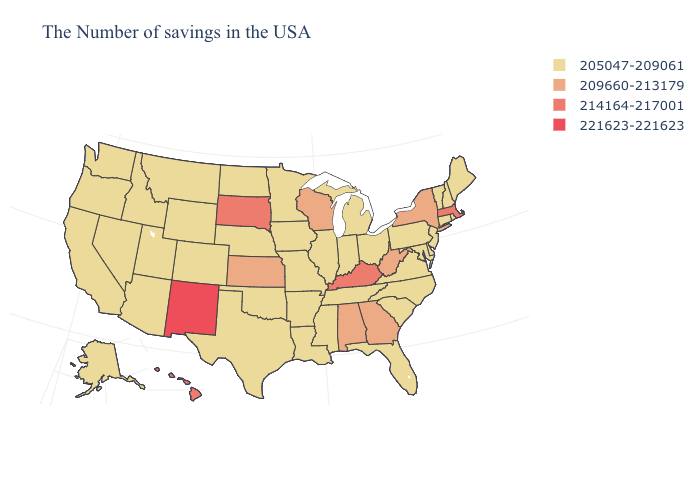What is the highest value in states that border California?
Short answer required. 205047-209061. Among the states that border North Dakota , does Minnesota have the lowest value?
Answer briefly. Yes. Does New York have the highest value in the USA?
Concise answer only. No. Does Indiana have the lowest value in the USA?
Quick response, please. Yes. What is the value of Iowa?
Quick response, please. 205047-209061. What is the lowest value in the Northeast?
Concise answer only. 205047-209061. Among the states that border Pennsylvania , does West Virginia have the highest value?
Concise answer only. Yes. Is the legend a continuous bar?
Give a very brief answer. No. Does West Virginia have the same value as Georgia?
Short answer required. Yes. Does Arizona have the lowest value in the USA?
Answer briefly. Yes. Does Kentucky have a higher value than Wisconsin?
Short answer required. Yes. What is the value of Idaho?
Short answer required. 205047-209061. What is the lowest value in states that border Georgia?
Quick response, please. 205047-209061. Name the states that have a value in the range 221623-221623?
Write a very short answer. New Mexico. Does South Dakota have a higher value than Kentucky?
Answer briefly. No. 